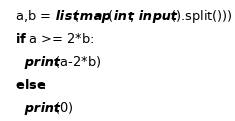<code> <loc_0><loc_0><loc_500><loc_500><_Python_>a,b = list(map(int, input().split()))
if a >= 2*b:
  print(a-2*b)
else:
  print(0)</code> 